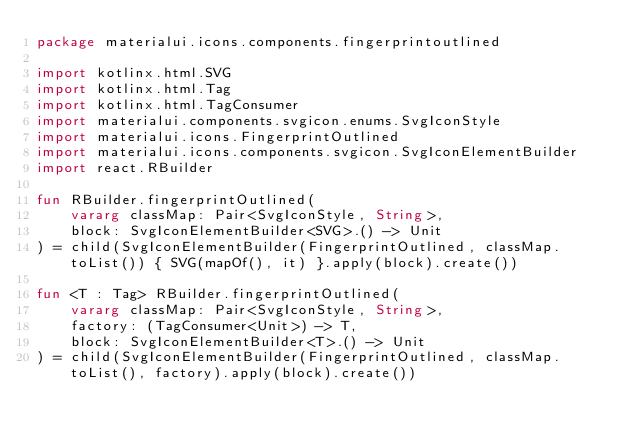<code> <loc_0><loc_0><loc_500><loc_500><_Kotlin_>package materialui.icons.components.fingerprintoutlined

import kotlinx.html.SVG
import kotlinx.html.Tag
import kotlinx.html.TagConsumer
import materialui.components.svgicon.enums.SvgIconStyle
import materialui.icons.FingerprintOutlined
import materialui.icons.components.svgicon.SvgIconElementBuilder
import react.RBuilder

fun RBuilder.fingerprintOutlined(
    vararg classMap: Pair<SvgIconStyle, String>,
    block: SvgIconElementBuilder<SVG>.() -> Unit
) = child(SvgIconElementBuilder(FingerprintOutlined, classMap.toList()) { SVG(mapOf(), it) }.apply(block).create())

fun <T : Tag> RBuilder.fingerprintOutlined(
    vararg classMap: Pair<SvgIconStyle, String>,
    factory: (TagConsumer<Unit>) -> T,
    block: SvgIconElementBuilder<T>.() -> Unit
) = child(SvgIconElementBuilder(FingerprintOutlined, classMap.toList(), factory).apply(block).create())
</code> 